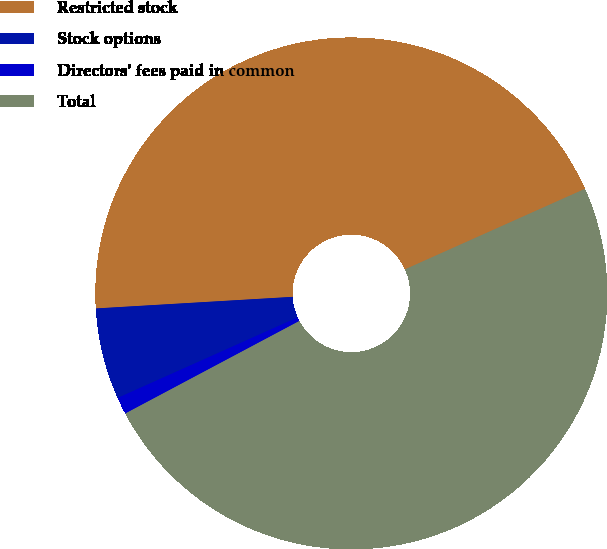Convert chart. <chart><loc_0><loc_0><loc_500><loc_500><pie_chart><fcel>Restricted stock<fcel>Stock options<fcel>Directors' fees paid in common<fcel>Total<nl><fcel>44.24%<fcel>5.76%<fcel>1.08%<fcel>48.92%<nl></chart> 